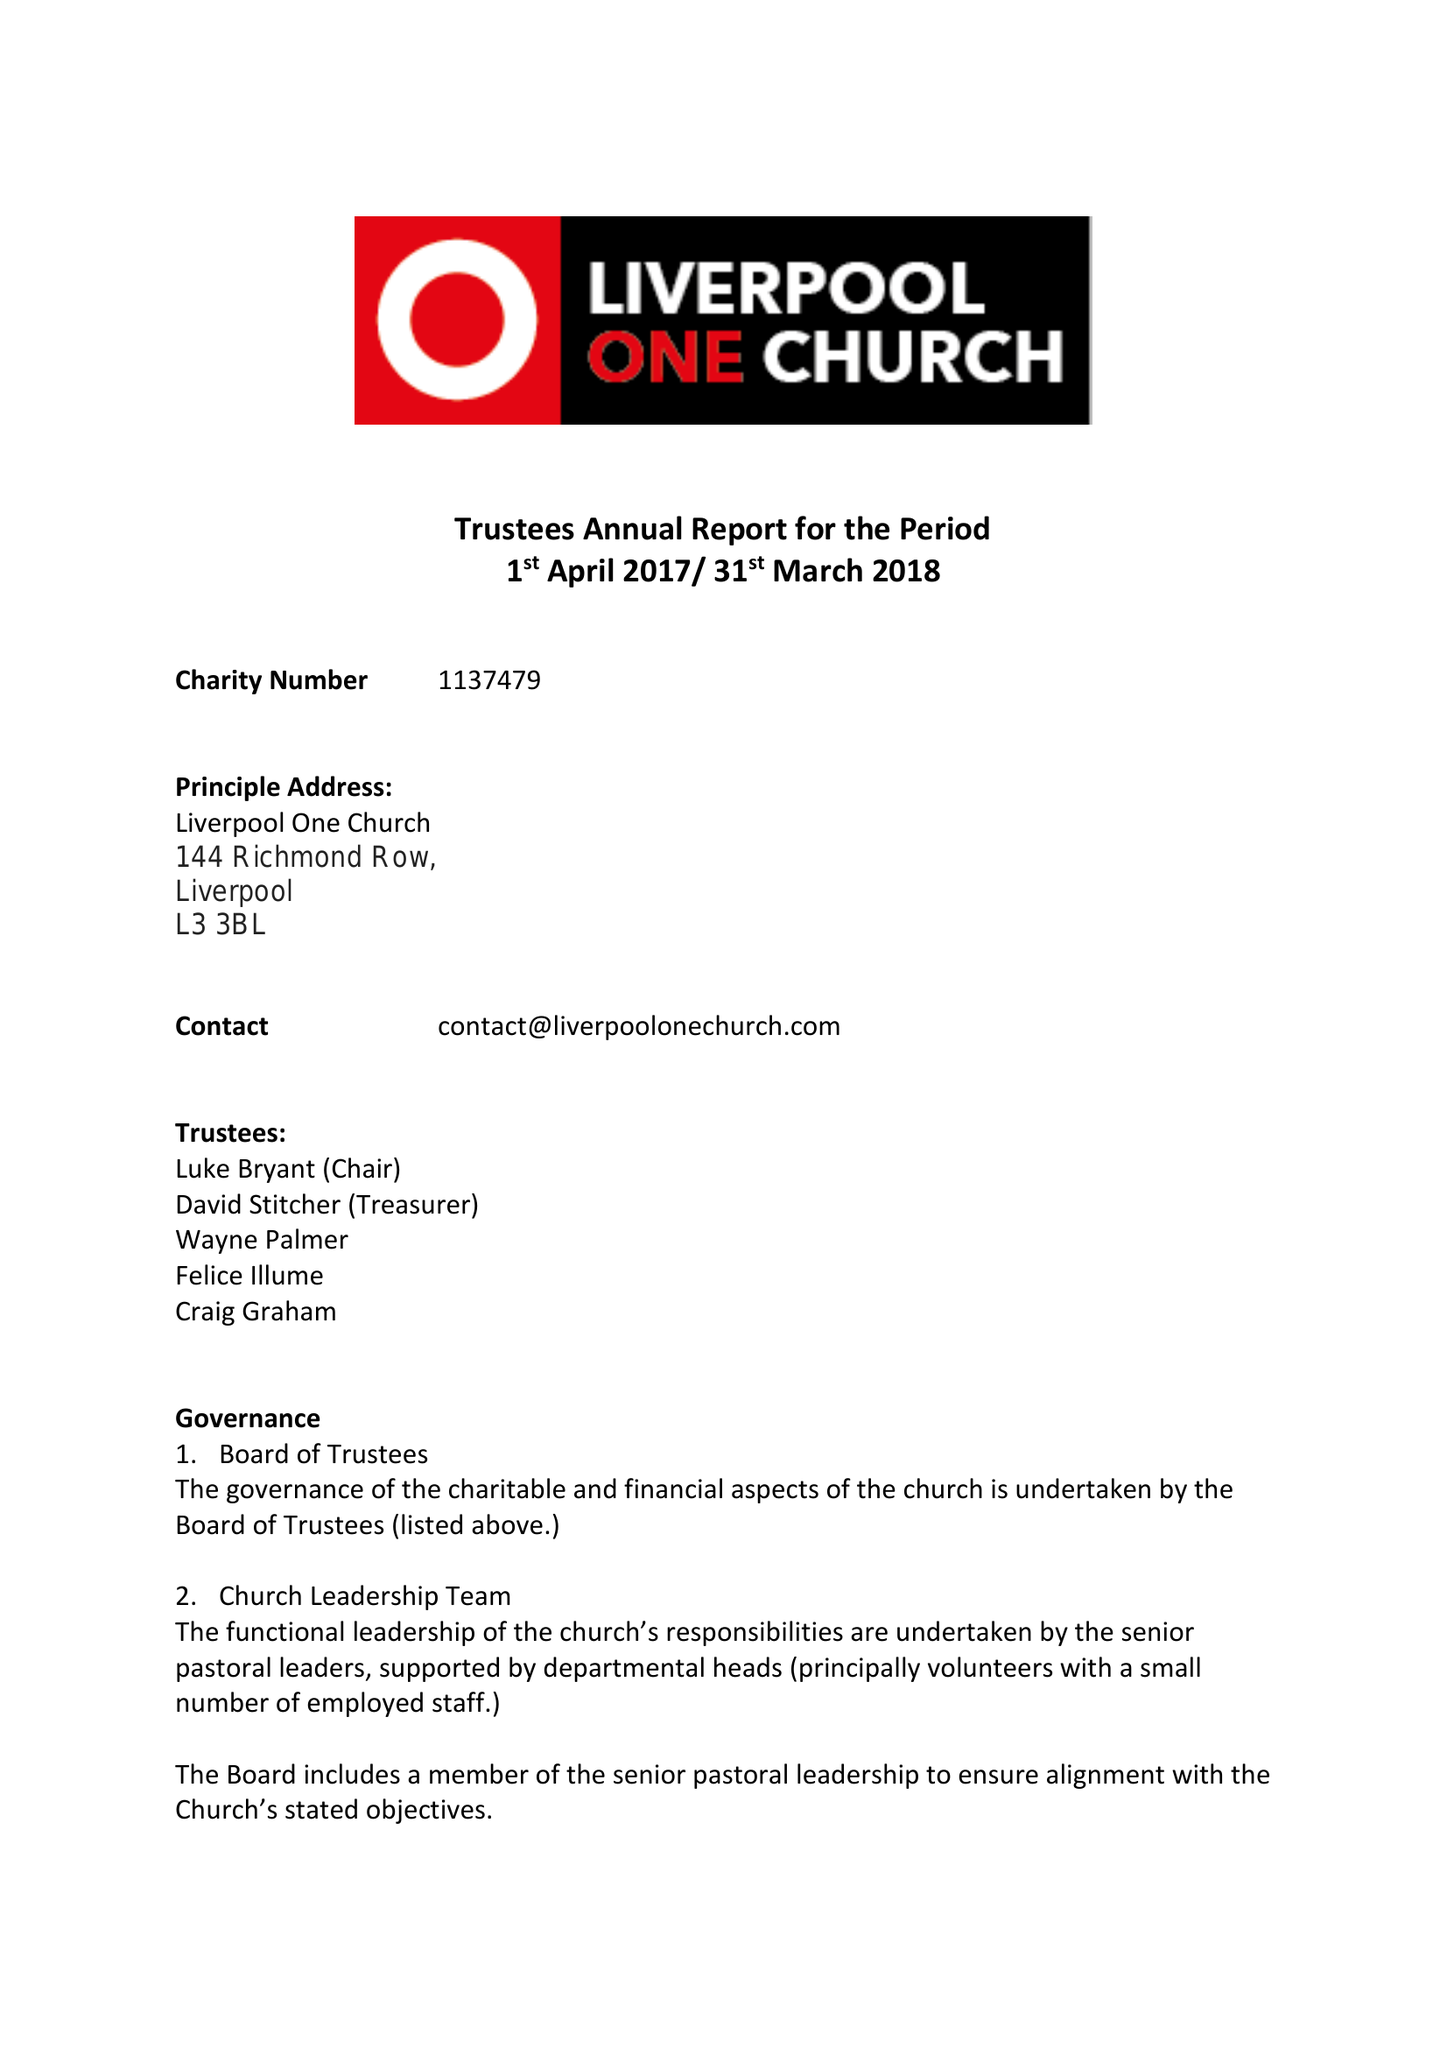What is the value for the charity_number?
Answer the question using a single word or phrase. 1137479 